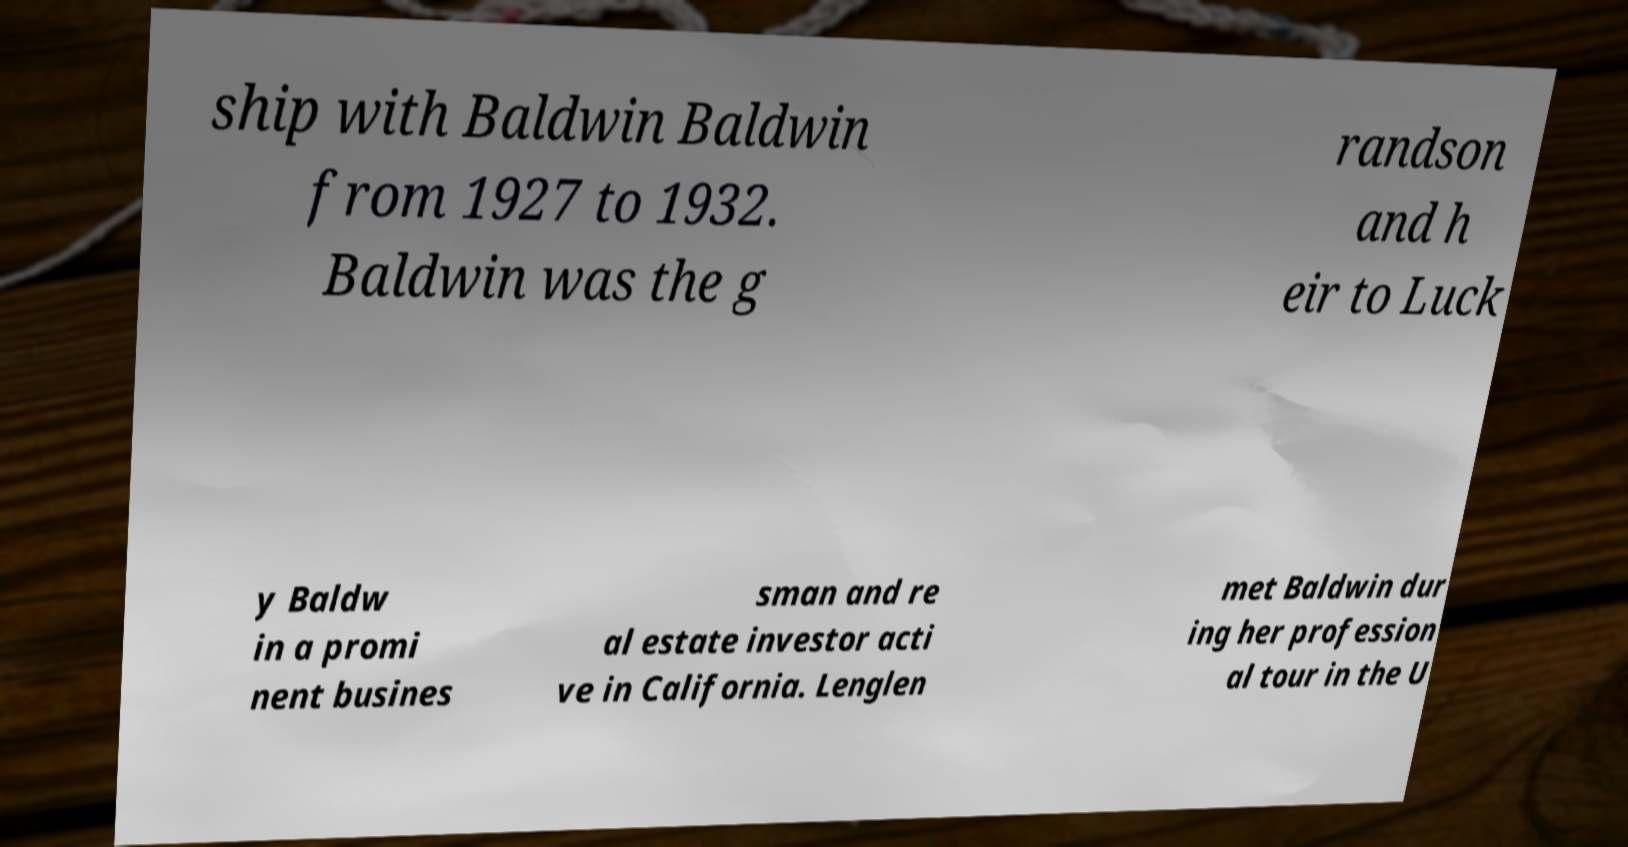For documentation purposes, I need the text within this image transcribed. Could you provide that? ship with Baldwin Baldwin from 1927 to 1932. Baldwin was the g randson and h eir to Luck y Baldw in a promi nent busines sman and re al estate investor acti ve in California. Lenglen met Baldwin dur ing her profession al tour in the U 